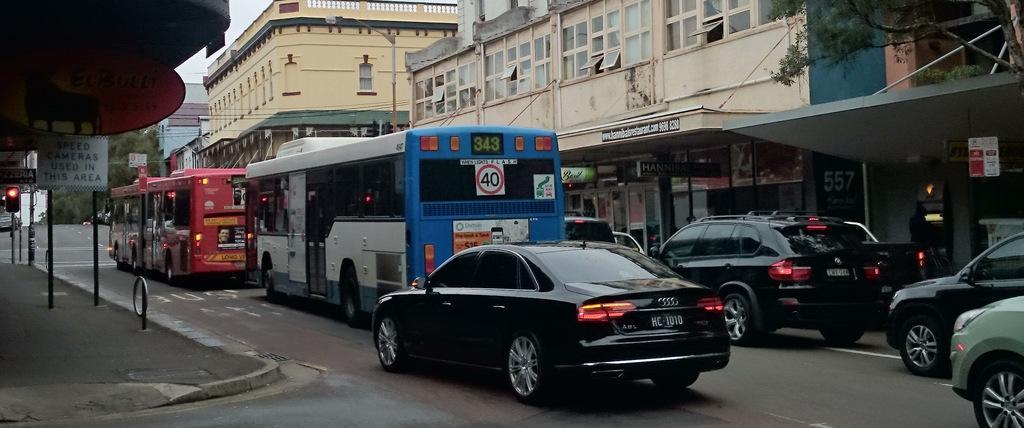Please provide a concise description of this image. Here a black color car is moving on the road there are two buses that are moving in front of this. In the right side there are buildings. 